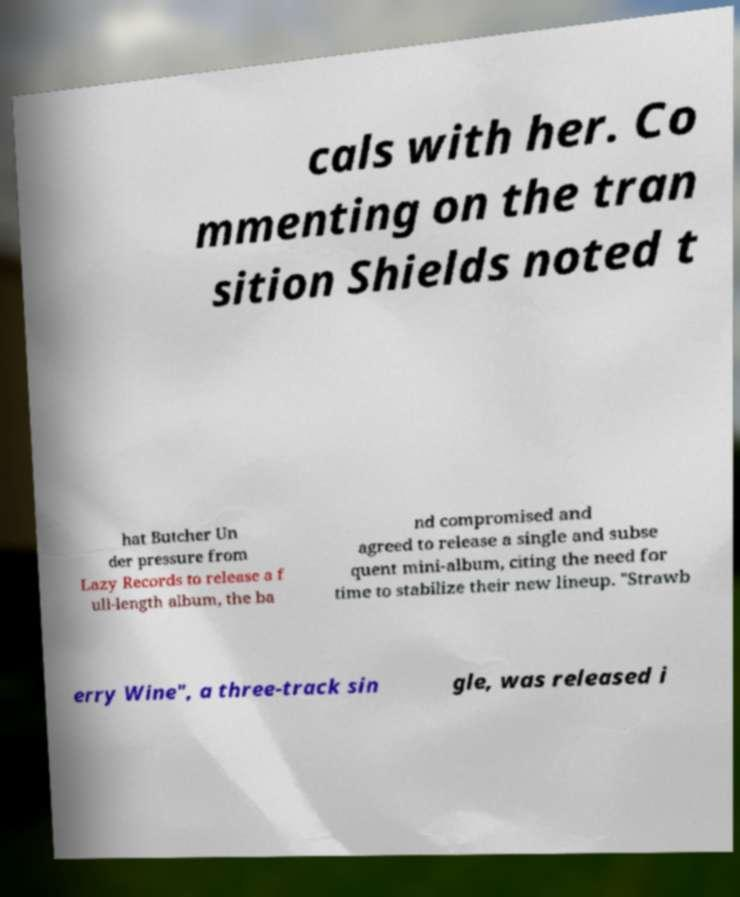Please identify and transcribe the text found in this image. cals with her. Co mmenting on the tran sition Shields noted t hat Butcher Un der pressure from Lazy Records to release a f ull-length album, the ba nd compromised and agreed to release a single and subse quent mini-album, citing the need for time to stabilize their new lineup. "Strawb erry Wine", a three-track sin gle, was released i 